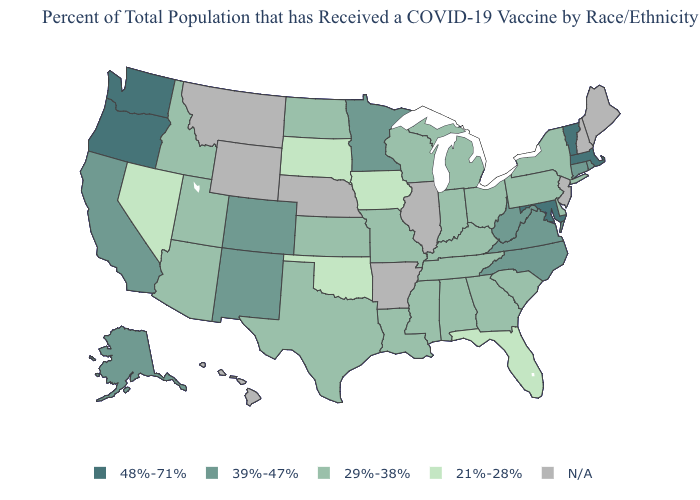Name the states that have a value in the range 48%-71%?
Write a very short answer. Maryland, Massachusetts, Oregon, Vermont, Washington. What is the value of Nevada?
Concise answer only. 21%-28%. Name the states that have a value in the range 29%-38%?
Concise answer only. Alabama, Arizona, Delaware, Georgia, Idaho, Indiana, Kansas, Kentucky, Louisiana, Michigan, Mississippi, Missouri, New York, North Dakota, Ohio, Pennsylvania, South Carolina, Tennessee, Texas, Utah, Wisconsin. Name the states that have a value in the range 29%-38%?
Keep it brief. Alabama, Arizona, Delaware, Georgia, Idaho, Indiana, Kansas, Kentucky, Louisiana, Michigan, Mississippi, Missouri, New York, North Dakota, Ohio, Pennsylvania, South Carolina, Tennessee, Texas, Utah, Wisconsin. Name the states that have a value in the range 39%-47%?
Concise answer only. Alaska, California, Colorado, Connecticut, Minnesota, New Mexico, North Carolina, Rhode Island, Virginia, West Virginia. Is the legend a continuous bar?
Be succinct. No. What is the value of New York?
Concise answer only. 29%-38%. Does Oklahoma have the lowest value in the South?
Write a very short answer. Yes. Name the states that have a value in the range 39%-47%?
Be succinct. Alaska, California, Colorado, Connecticut, Minnesota, New Mexico, North Carolina, Rhode Island, Virginia, West Virginia. Does Massachusetts have the lowest value in the Northeast?
Give a very brief answer. No. Name the states that have a value in the range 29%-38%?
Answer briefly. Alabama, Arizona, Delaware, Georgia, Idaho, Indiana, Kansas, Kentucky, Louisiana, Michigan, Mississippi, Missouri, New York, North Dakota, Ohio, Pennsylvania, South Carolina, Tennessee, Texas, Utah, Wisconsin. Name the states that have a value in the range 21%-28%?
Concise answer only. Florida, Iowa, Nevada, Oklahoma, South Dakota. What is the highest value in the MidWest ?
Short answer required. 39%-47%. Among the states that border Arkansas , which have the lowest value?
Quick response, please. Oklahoma. Does Massachusetts have the lowest value in the Northeast?
Quick response, please. No. 